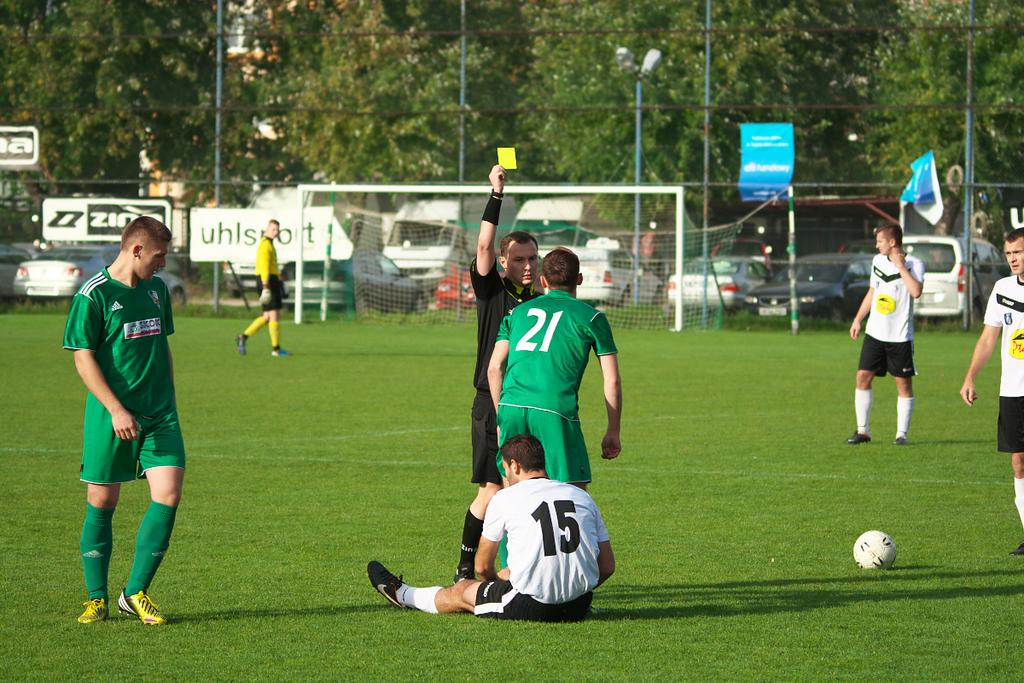<image>
Describe the image concisely. A soccer player whose number is 21 is being given a yellow card by the referee. 